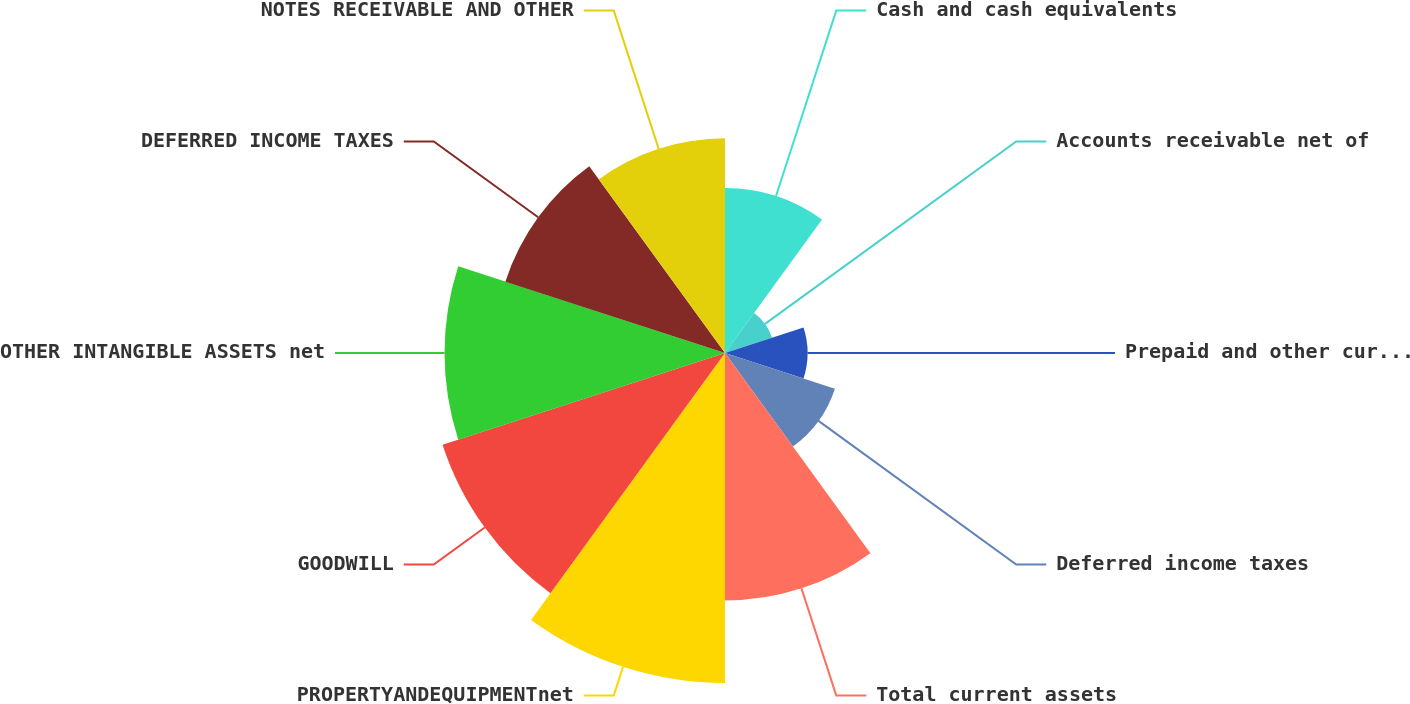<chart> <loc_0><loc_0><loc_500><loc_500><pie_chart><fcel>Cash and cash equivalents<fcel>Accounts receivable net of<fcel>Prepaid and other current<fcel>Deferred income taxes<fcel>Total current assets<fcel>PROPERTYANDEQUIPMENTnet<fcel>GOODWILL<fcel>OTHER INTANGIBLE ASSETS net<fcel>DEFERRED INCOME TAXES<fcel>NOTES RECEIVABLE AND OTHER<nl><fcel>8.2%<fcel>2.46%<fcel>4.1%<fcel>5.74%<fcel>12.29%<fcel>16.39%<fcel>14.75%<fcel>13.93%<fcel>11.47%<fcel>10.66%<nl></chart> 